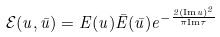<formula> <loc_0><loc_0><loc_500><loc_500>\mathcal { E } ( u , \bar { u } ) = E ( u ) \bar { E } ( \bar { u } ) e ^ { - \frac { 2 ( \text {Im} u ) ^ { 2 } } { \pi \text {Im} \tau } }</formula> 